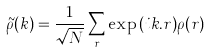Convert formula to latex. <formula><loc_0><loc_0><loc_500><loc_500>\tilde { \rho } ( { k } ) = \frac { 1 } { \sqrt { N } } \sum _ { r } \exp { ( i { k . r } ) } \rho ( { r } )</formula> 